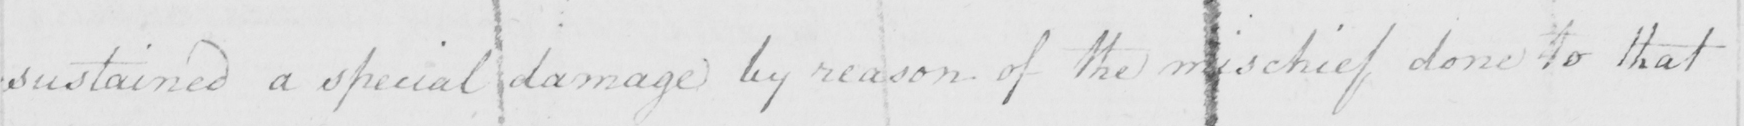What text is written in this handwritten line? sustained a special damage by reason of the mischief done to that 